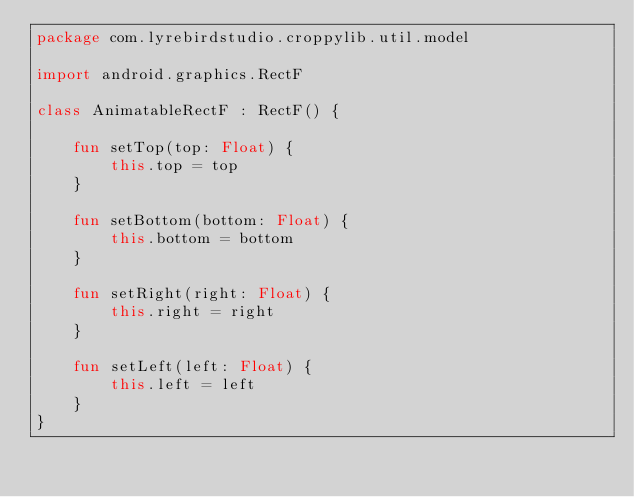<code> <loc_0><loc_0><loc_500><loc_500><_Kotlin_>package com.lyrebirdstudio.croppylib.util.model

import android.graphics.RectF

class AnimatableRectF : RectF() {

    fun setTop(top: Float) {
        this.top = top
    }

    fun setBottom(bottom: Float) {
        this.bottom = bottom
    }

    fun setRight(right: Float) {
        this.right = right
    }

    fun setLeft(left: Float) {
        this.left = left
    }
}</code> 